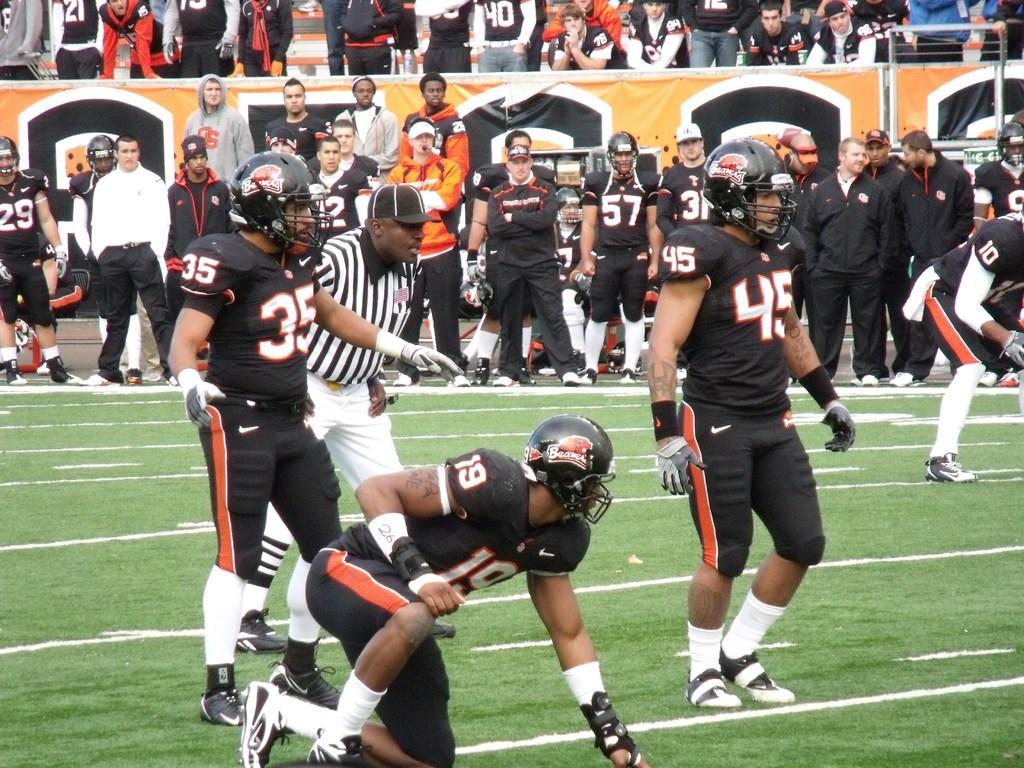In one or two sentences, can you explain what this image depicts? There are groups of people standing. Here is a person sitting in squat position. This looks like a hoarding. I think this is a ground. 